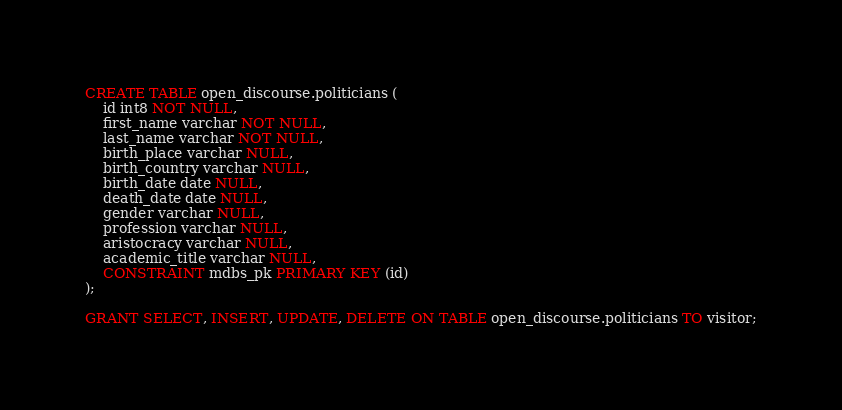Convert code to text. <code><loc_0><loc_0><loc_500><loc_500><_SQL_>CREATE TABLE open_discourse.politicians (
	id int8 NOT NULL,
	first_name varchar NOT NULL,
	last_name varchar NOT NULL,
	birth_place varchar NULL,
	birth_country varchar NULL,
	birth_date date NULL,
	death_date date NULL,
	gender varchar NULL,
	profession varchar NULL,
	aristocracy varchar NULL,
	academic_title varchar NULL,
	CONSTRAINT mdbs_pk PRIMARY KEY (id)
);

GRANT SELECT, INSERT, UPDATE, DELETE ON TABLE open_discourse.politicians TO visitor;
</code> 